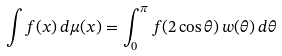<formula> <loc_0><loc_0><loc_500><loc_500>\int f ( x ) \, d \mu ( x ) = \int _ { 0 } ^ { \pi } f ( 2 \cos \theta ) \, w ( \theta ) \, d \theta</formula> 